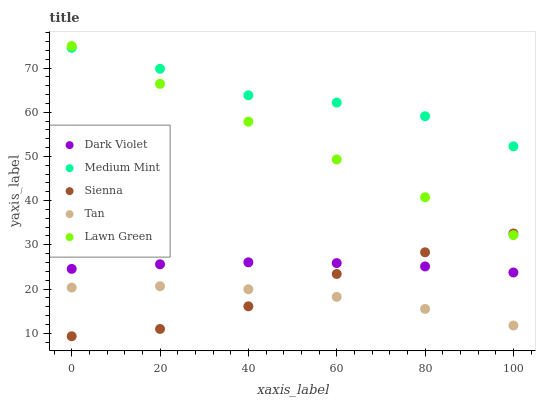Does Tan have the minimum area under the curve?
Answer yes or no. Yes. Does Medium Mint have the maximum area under the curve?
Answer yes or no. Yes. Does Sienna have the minimum area under the curve?
Answer yes or no. No. Does Sienna have the maximum area under the curve?
Answer yes or no. No. Is Lawn Green the smoothest?
Answer yes or no. Yes. Is Medium Mint the roughest?
Answer yes or no. Yes. Is Sienna the smoothest?
Answer yes or no. No. Is Sienna the roughest?
Answer yes or no. No. Does Sienna have the lowest value?
Answer yes or no. Yes. Does Tan have the lowest value?
Answer yes or no. No. Does Lawn Green have the highest value?
Answer yes or no. Yes. Does Sienna have the highest value?
Answer yes or no. No. Is Sienna less than Medium Mint?
Answer yes or no. Yes. Is Dark Violet greater than Tan?
Answer yes or no. Yes. Does Sienna intersect Lawn Green?
Answer yes or no. Yes. Is Sienna less than Lawn Green?
Answer yes or no. No. Is Sienna greater than Lawn Green?
Answer yes or no. No. Does Sienna intersect Medium Mint?
Answer yes or no. No. 